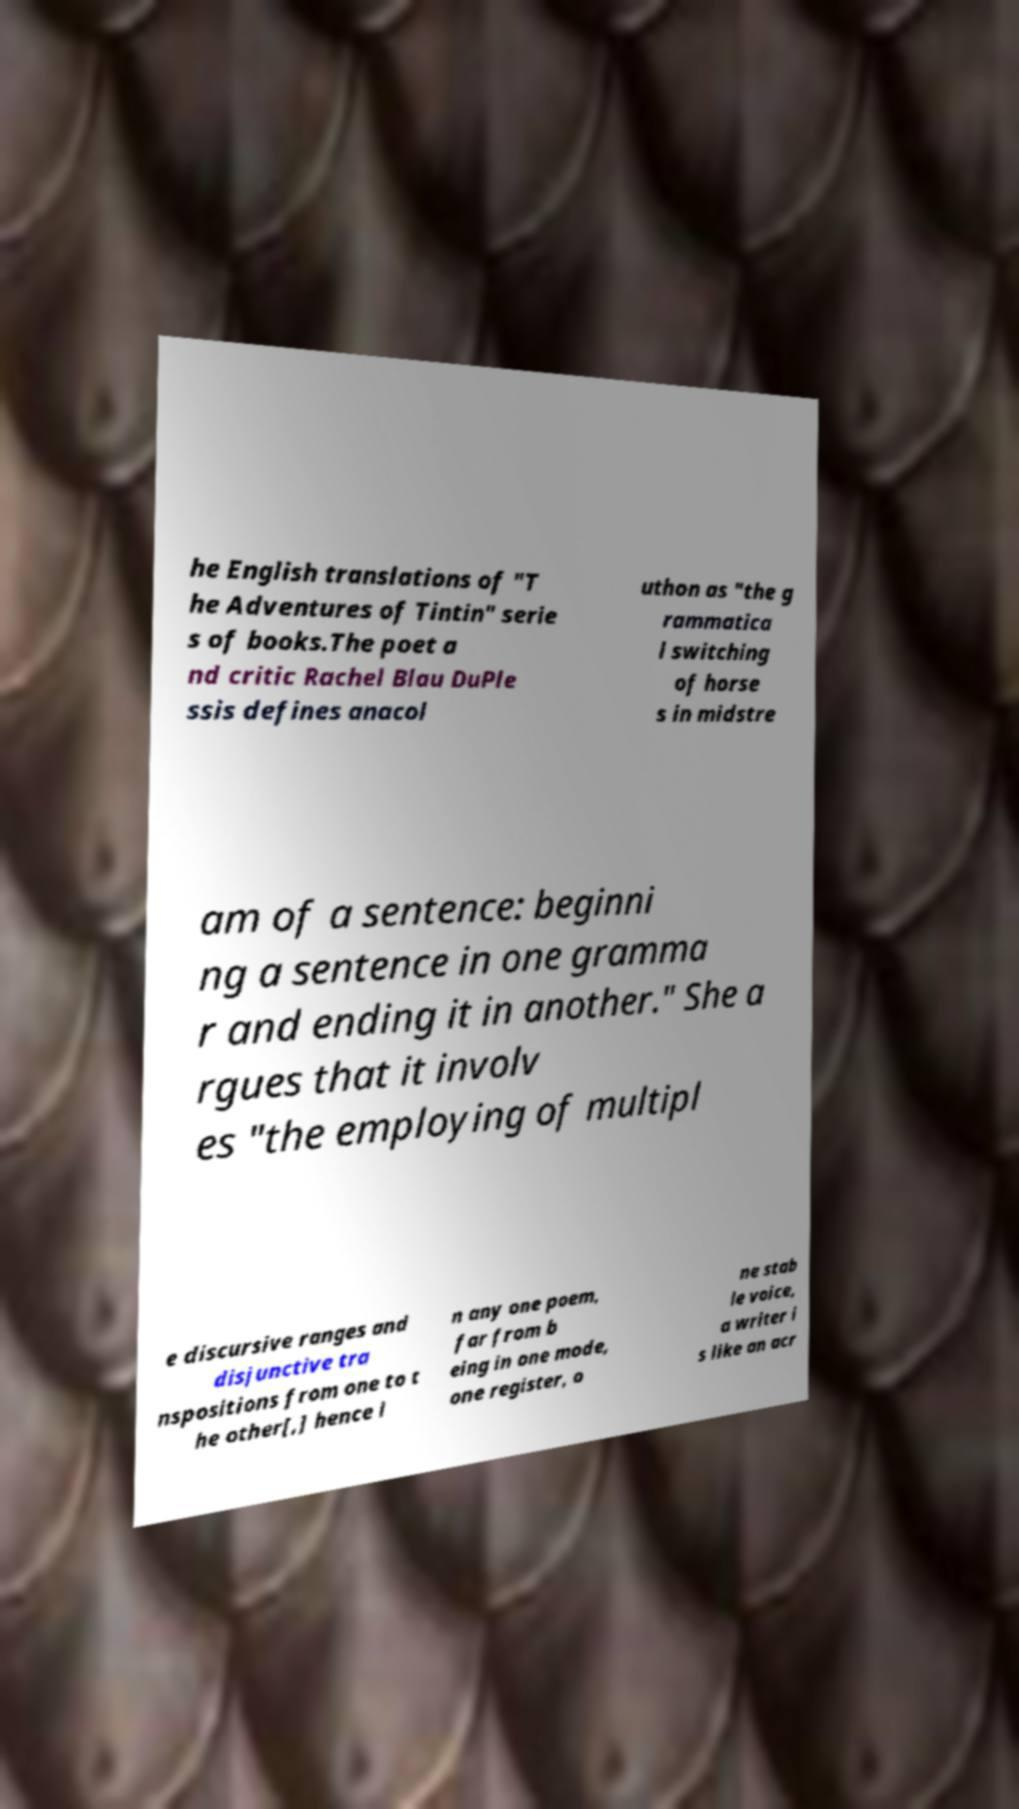Could you assist in decoding the text presented in this image and type it out clearly? he English translations of "T he Adventures of Tintin" serie s of books.The poet a nd critic Rachel Blau DuPle ssis defines anacol uthon as "the g rammatica l switching of horse s in midstre am of a sentence: beginni ng a sentence in one gramma r and ending it in another." She a rgues that it involv es "the employing of multipl e discursive ranges and disjunctive tra nspositions from one to t he other[,] hence i n any one poem, far from b eing in one mode, one register, o ne stab le voice, a writer i s like an acr 